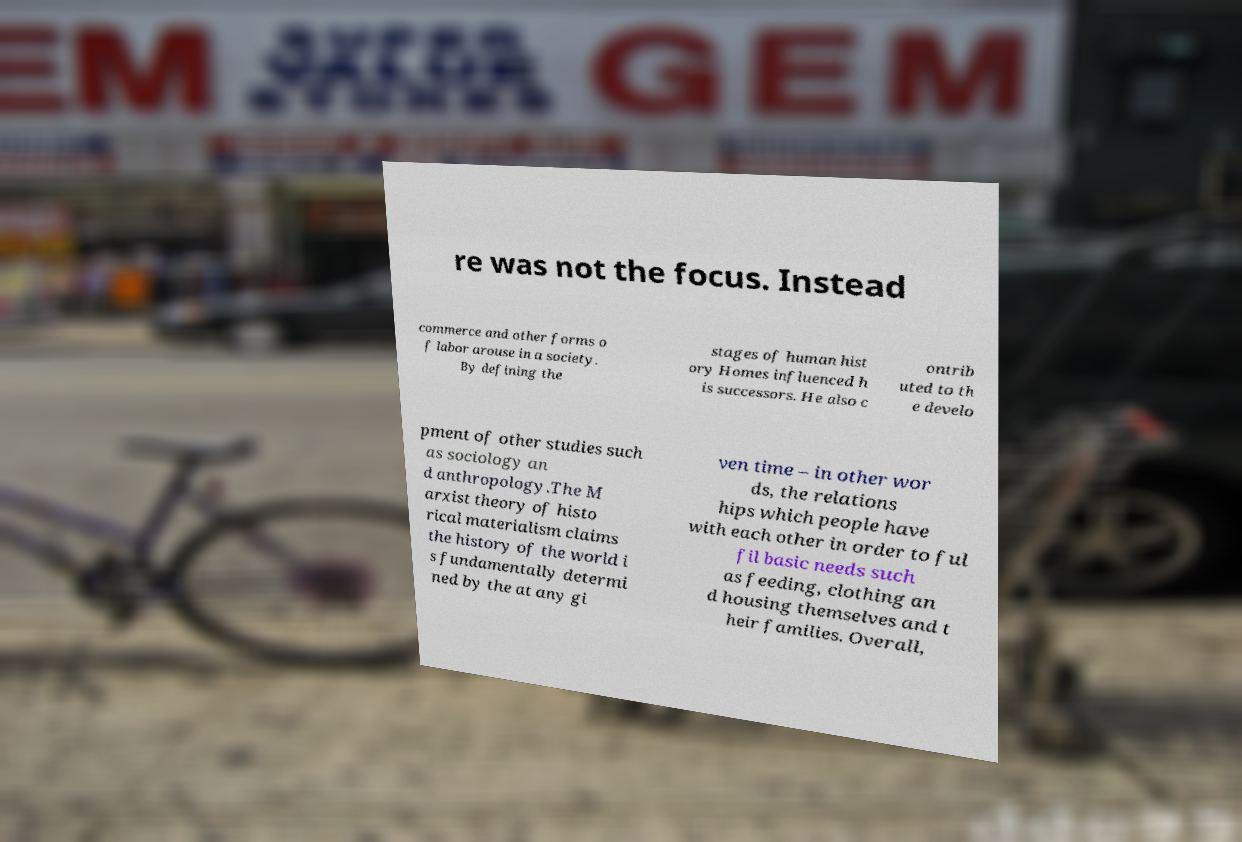There's text embedded in this image that I need extracted. Can you transcribe it verbatim? re was not the focus. Instead commerce and other forms o f labor arouse in a society. By defining the stages of human hist ory Homes influenced h is successors. He also c ontrib uted to th e develo pment of other studies such as sociology an d anthropology.The M arxist theory of histo rical materialism claims the history of the world i s fundamentally determi ned by the at any gi ven time – in other wor ds, the relations hips which people have with each other in order to ful fil basic needs such as feeding, clothing an d housing themselves and t heir families. Overall, 